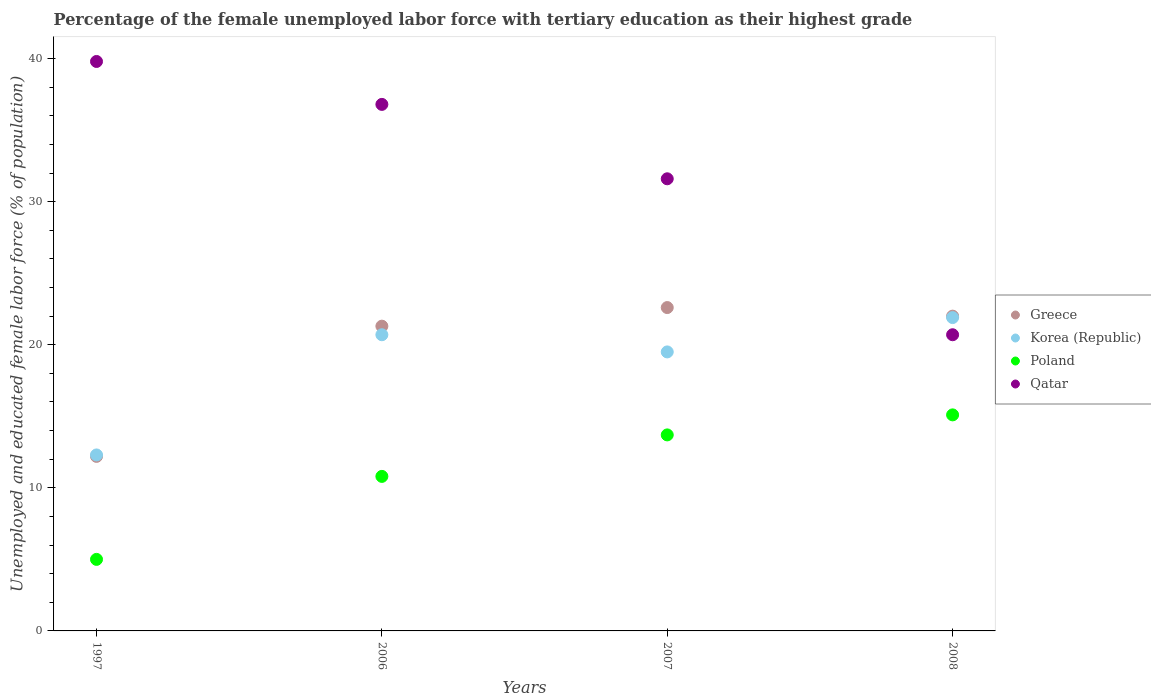Is the number of dotlines equal to the number of legend labels?
Offer a very short reply. Yes. Across all years, what is the maximum percentage of the unemployed female labor force with tertiary education in Qatar?
Provide a short and direct response. 39.8. Across all years, what is the minimum percentage of the unemployed female labor force with tertiary education in Qatar?
Give a very brief answer. 20.7. What is the total percentage of the unemployed female labor force with tertiary education in Korea (Republic) in the graph?
Keep it short and to the point. 74.4. What is the difference between the percentage of the unemployed female labor force with tertiary education in Qatar in 2007 and that in 2008?
Provide a short and direct response. 10.9. What is the difference between the percentage of the unemployed female labor force with tertiary education in Greece in 2007 and the percentage of the unemployed female labor force with tertiary education in Qatar in 2008?
Offer a very short reply. 1.9. What is the average percentage of the unemployed female labor force with tertiary education in Greece per year?
Make the answer very short. 19.52. In the year 2008, what is the difference between the percentage of the unemployed female labor force with tertiary education in Greece and percentage of the unemployed female labor force with tertiary education in Poland?
Your response must be concise. 6.9. In how many years, is the percentage of the unemployed female labor force with tertiary education in Korea (Republic) greater than 38 %?
Provide a short and direct response. 0. What is the ratio of the percentage of the unemployed female labor force with tertiary education in Korea (Republic) in 1997 to that in 2007?
Your response must be concise. 0.63. Is the difference between the percentage of the unemployed female labor force with tertiary education in Greece in 1997 and 2007 greater than the difference between the percentage of the unemployed female labor force with tertiary education in Poland in 1997 and 2007?
Give a very brief answer. No. What is the difference between the highest and the second highest percentage of the unemployed female labor force with tertiary education in Korea (Republic)?
Ensure brevity in your answer.  1.2. What is the difference between the highest and the lowest percentage of the unemployed female labor force with tertiary education in Korea (Republic)?
Offer a very short reply. 9.6. In how many years, is the percentage of the unemployed female labor force with tertiary education in Greece greater than the average percentage of the unemployed female labor force with tertiary education in Greece taken over all years?
Keep it short and to the point. 3. Is it the case that in every year, the sum of the percentage of the unemployed female labor force with tertiary education in Korea (Republic) and percentage of the unemployed female labor force with tertiary education in Qatar  is greater than the sum of percentage of the unemployed female labor force with tertiary education in Greece and percentage of the unemployed female labor force with tertiary education in Poland?
Provide a succinct answer. Yes. Is it the case that in every year, the sum of the percentage of the unemployed female labor force with tertiary education in Poland and percentage of the unemployed female labor force with tertiary education in Qatar  is greater than the percentage of the unemployed female labor force with tertiary education in Korea (Republic)?
Make the answer very short. Yes. Is the percentage of the unemployed female labor force with tertiary education in Qatar strictly greater than the percentage of the unemployed female labor force with tertiary education in Greece over the years?
Provide a short and direct response. No. How many dotlines are there?
Give a very brief answer. 4. Does the graph contain grids?
Offer a terse response. No. How many legend labels are there?
Your response must be concise. 4. How are the legend labels stacked?
Make the answer very short. Vertical. What is the title of the graph?
Your answer should be compact. Percentage of the female unemployed labor force with tertiary education as their highest grade. Does "Gabon" appear as one of the legend labels in the graph?
Keep it short and to the point. No. What is the label or title of the Y-axis?
Your answer should be very brief. Unemployed and educated female labor force (% of population). What is the Unemployed and educated female labor force (% of population) of Greece in 1997?
Offer a terse response. 12.2. What is the Unemployed and educated female labor force (% of population) in Korea (Republic) in 1997?
Keep it short and to the point. 12.3. What is the Unemployed and educated female labor force (% of population) of Poland in 1997?
Make the answer very short. 5. What is the Unemployed and educated female labor force (% of population) in Qatar in 1997?
Your response must be concise. 39.8. What is the Unemployed and educated female labor force (% of population) in Greece in 2006?
Keep it short and to the point. 21.3. What is the Unemployed and educated female labor force (% of population) of Korea (Republic) in 2006?
Your response must be concise. 20.7. What is the Unemployed and educated female labor force (% of population) in Poland in 2006?
Your response must be concise. 10.8. What is the Unemployed and educated female labor force (% of population) of Qatar in 2006?
Your answer should be compact. 36.8. What is the Unemployed and educated female labor force (% of population) in Greece in 2007?
Offer a terse response. 22.6. What is the Unemployed and educated female labor force (% of population) of Poland in 2007?
Your response must be concise. 13.7. What is the Unemployed and educated female labor force (% of population) of Qatar in 2007?
Your answer should be compact. 31.6. What is the Unemployed and educated female labor force (% of population) in Greece in 2008?
Make the answer very short. 22. What is the Unemployed and educated female labor force (% of population) of Korea (Republic) in 2008?
Give a very brief answer. 21.9. What is the Unemployed and educated female labor force (% of population) of Poland in 2008?
Give a very brief answer. 15.1. What is the Unemployed and educated female labor force (% of population) of Qatar in 2008?
Ensure brevity in your answer.  20.7. Across all years, what is the maximum Unemployed and educated female labor force (% of population) in Greece?
Keep it short and to the point. 22.6. Across all years, what is the maximum Unemployed and educated female labor force (% of population) in Korea (Republic)?
Keep it short and to the point. 21.9. Across all years, what is the maximum Unemployed and educated female labor force (% of population) in Poland?
Provide a short and direct response. 15.1. Across all years, what is the maximum Unemployed and educated female labor force (% of population) in Qatar?
Keep it short and to the point. 39.8. Across all years, what is the minimum Unemployed and educated female labor force (% of population) of Greece?
Ensure brevity in your answer.  12.2. Across all years, what is the minimum Unemployed and educated female labor force (% of population) of Korea (Republic)?
Make the answer very short. 12.3. Across all years, what is the minimum Unemployed and educated female labor force (% of population) in Qatar?
Give a very brief answer. 20.7. What is the total Unemployed and educated female labor force (% of population) in Greece in the graph?
Offer a terse response. 78.1. What is the total Unemployed and educated female labor force (% of population) of Korea (Republic) in the graph?
Give a very brief answer. 74.4. What is the total Unemployed and educated female labor force (% of population) in Poland in the graph?
Ensure brevity in your answer.  44.6. What is the total Unemployed and educated female labor force (% of population) in Qatar in the graph?
Your answer should be very brief. 128.9. What is the difference between the Unemployed and educated female labor force (% of population) of Greece in 1997 and that in 2006?
Make the answer very short. -9.1. What is the difference between the Unemployed and educated female labor force (% of population) of Korea (Republic) in 1997 and that in 2006?
Your response must be concise. -8.4. What is the difference between the Unemployed and educated female labor force (% of population) in Greece in 1997 and that in 2007?
Offer a terse response. -10.4. What is the difference between the Unemployed and educated female labor force (% of population) in Qatar in 1997 and that in 2007?
Ensure brevity in your answer.  8.2. What is the difference between the Unemployed and educated female labor force (% of population) of Greece in 1997 and that in 2008?
Your answer should be very brief. -9.8. What is the difference between the Unemployed and educated female labor force (% of population) in Korea (Republic) in 1997 and that in 2008?
Offer a terse response. -9.6. What is the difference between the Unemployed and educated female labor force (% of population) in Poland in 1997 and that in 2008?
Give a very brief answer. -10.1. What is the difference between the Unemployed and educated female labor force (% of population) of Qatar in 1997 and that in 2008?
Keep it short and to the point. 19.1. What is the difference between the Unemployed and educated female labor force (% of population) of Greece in 2006 and that in 2007?
Ensure brevity in your answer.  -1.3. What is the difference between the Unemployed and educated female labor force (% of population) of Korea (Republic) in 2006 and that in 2007?
Your answer should be compact. 1.2. What is the difference between the Unemployed and educated female labor force (% of population) in Poland in 2006 and that in 2007?
Offer a very short reply. -2.9. What is the difference between the Unemployed and educated female labor force (% of population) of Qatar in 2006 and that in 2007?
Your answer should be compact. 5.2. What is the difference between the Unemployed and educated female labor force (% of population) in Greece in 2006 and that in 2008?
Keep it short and to the point. -0.7. What is the difference between the Unemployed and educated female labor force (% of population) of Korea (Republic) in 2006 and that in 2008?
Your answer should be very brief. -1.2. What is the difference between the Unemployed and educated female labor force (% of population) of Poland in 2006 and that in 2008?
Your answer should be compact. -4.3. What is the difference between the Unemployed and educated female labor force (% of population) of Greece in 2007 and that in 2008?
Provide a succinct answer. 0.6. What is the difference between the Unemployed and educated female labor force (% of population) in Korea (Republic) in 2007 and that in 2008?
Your answer should be compact. -2.4. What is the difference between the Unemployed and educated female labor force (% of population) of Poland in 2007 and that in 2008?
Provide a short and direct response. -1.4. What is the difference between the Unemployed and educated female labor force (% of population) of Greece in 1997 and the Unemployed and educated female labor force (% of population) of Korea (Republic) in 2006?
Your response must be concise. -8.5. What is the difference between the Unemployed and educated female labor force (% of population) of Greece in 1997 and the Unemployed and educated female labor force (% of population) of Poland in 2006?
Keep it short and to the point. 1.4. What is the difference between the Unemployed and educated female labor force (% of population) in Greece in 1997 and the Unemployed and educated female labor force (% of population) in Qatar in 2006?
Your answer should be very brief. -24.6. What is the difference between the Unemployed and educated female labor force (% of population) in Korea (Republic) in 1997 and the Unemployed and educated female labor force (% of population) in Qatar in 2006?
Your answer should be very brief. -24.5. What is the difference between the Unemployed and educated female labor force (% of population) of Poland in 1997 and the Unemployed and educated female labor force (% of population) of Qatar in 2006?
Your answer should be compact. -31.8. What is the difference between the Unemployed and educated female labor force (% of population) of Greece in 1997 and the Unemployed and educated female labor force (% of population) of Qatar in 2007?
Your answer should be very brief. -19.4. What is the difference between the Unemployed and educated female labor force (% of population) of Korea (Republic) in 1997 and the Unemployed and educated female labor force (% of population) of Poland in 2007?
Make the answer very short. -1.4. What is the difference between the Unemployed and educated female labor force (% of population) in Korea (Republic) in 1997 and the Unemployed and educated female labor force (% of population) in Qatar in 2007?
Give a very brief answer. -19.3. What is the difference between the Unemployed and educated female labor force (% of population) of Poland in 1997 and the Unemployed and educated female labor force (% of population) of Qatar in 2007?
Offer a very short reply. -26.6. What is the difference between the Unemployed and educated female labor force (% of population) of Greece in 1997 and the Unemployed and educated female labor force (% of population) of Poland in 2008?
Your answer should be very brief. -2.9. What is the difference between the Unemployed and educated female labor force (% of population) of Greece in 1997 and the Unemployed and educated female labor force (% of population) of Qatar in 2008?
Your answer should be compact. -8.5. What is the difference between the Unemployed and educated female labor force (% of population) of Poland in 1997 and the Unemployed and educated female labor force (% of population) of Qatar in 2008?
Give a very brief answer. -15.7. What is the difference between the Unemployed and educated female labor force (% of population) in Greece in 2006 and the Unemployed and educated female labor force (% of population) in Poland in 2007?
Your response must be concise. 7.6. What is the difference between the Unemployed and educated female labor force (% of population) of Korea (Republic) in 2006 and the Unemployed and educated female labor force (% of population) of Poland in 2007?
Offer a very short reply. 7. What is the difference between the Unemployed and educated female labor force (% of population) in Korea (Republic) in 2006 and the Unemployed and educated female labor force (% of population) in Qatar in 2007?
Provide a succinct answer. -10.9. What is the difference between the Unemployed and educated female labor force (% of population) of Poland in 2006 and the Unemployed and educated female labor force (% of population) of Qatar in 2007?
Your answer should be compact. -20.8. What is the difference between the Unemployed and educated female labor force (% of population) in Greece in 2006 and the Unemployed and educated female labor force (% of population) in Qatar in 2008?
Offer a very short reply. 0.6. What is the difference between the Unemployed and educated female labor force (% of population) in Korea (Republic) in 2006 and the Unemployed and educated female labor force (% of population) in Qatar in 2008?
Your response must be concise. 0. What is the difference between the Unemployed and educated female labor force (% of population) of Greece in 2007 and the Unemployed and educated female labor force (% of population) of Poland in 2008?
Offer a terse response. 7.5. What is the average Unemployed and educated female labor force (% of population) in Greece per year?
Provide a short and direct response. 19.52. What is the average Unemployed and educated female labor force (% of population) in Korea (Republic) per year?
Offer a very short reply. 18.6. What is the average Unemployed and educated female labor force (% of population) of Poland per year?
Provide a short and direct response. 11.15. What is the average Unemployed and educated female labor force (% of population) of Qatar per year?
Provide a succinct answer. 32.23. In the year 1997, what is the difference between the Unemployed and educated female labor force (% of population) in Greece and Unemployed and educated female labor force (% of population) in Qatar?
Keep it short and to the point. -27.6. In the year 1997, what is the difference between the Unemployed and educated female labor force (% of population) in Korea (Republic) and Unemployed and educated female labor force (% of population) in Qatar?
Provide a short and direct response. -27.5. In the year 1997, what is the difference between the Unemployed and educated female labor force (% of population) of Poland and Unemployed and educated female labor force (% of population) of Qatar?
Provide a succinct answer. -34.8. In the year 2006, what is the difference between the Unemployed and educated female labor force (% of population) of Greece and Unemployed and educated female labor force (% of population) of Korea (Republic)?
Your answer should be very brief. 0.6. In the year 2006, what is the difference between the Unemployed and educated female labor force (% of population) in Greece and Unemployed and educated female labor force (% of population) in Poland?
Ensure brevity in your answer.  10.5. In the year 2006, what is the difference between the Unemployed and educated female labor force (% of population) of Greece and Unemployed and educated female labor force (% of population) of Qatar?
Offer a terse response. -15.5. In the year 2006, what is the difference between the Unemployed and educated female labor force (% of population) in Korea (Republic) and Unemployed and educated female labor force (% of population) in Qatar?
Give a very brief answer. -16.1. In the year 2006, what is the difference between the Unemployed and educated female labor force (% of population) of Poland and Unemployed and educated female labor force (% of population) of Qatar?
Give a very brief answer. -26. In the year 2007, what is the difference between the Unemployed and educated female labor force (% of population) in Greece and Unemployed and educated female labor force (% of population) in Korea (Republic)?
Provide a short and direct response. 3.1. In the year 2007, what is the difference between the Unemployed and educated female labor force (% of population) of Greece and Unemployed and educated female labor force (% of population) of Poland?
Offer a terse response. 8.9. In the year 2007, what is the difference between the Unemployed and educated female labor force (% of population) in Greece and Unemployed and educated female labor force (% of population) in Qatar?
Offer a very short reply. -9. In the year 2007, what is the difference between the Unemployed and educated female labor force (% of population) in Korea (Republic) and Unemployed and educated female labor force (% of population) in Qatar?
Your response must be concise. -12.1. In the year 2007, what is the difference between the Unemployed and educated female labor force (% of population) in Poland and Unemployed and educated female labor force (% of population) in Qatar?
Offer a terse response. -17.9. In the year 2008, what is the difference between the Unemployed and educated female labor force (% of population) of Greece and Unemployed and educated female labor force (% of population) of Qatar?
Make the answer very short. 1.3. In the year 2008, what is the difference between the Unemployed and educated female labor force (% of population) of Korea (Republic) and Unemployed and educated female labor force (% of population) of Poland?
Keep it short and to the point. 6.8. In the year 2008, what is the difference between the Unemployed and educated female labor force (% of population) of Korea (Republic) and Unemployed and educated female labor force (% of population) of Qatar?
Ensure brevity in your answer.  1.2. In the year 2008, what is the difference between the Unemployed and educated female labor force (% of population) in Poland and Unemployed and educated female labor force (% of population) in Qatar?
Provide a short and direct response. -5.6. What is the ratio of the Unemployed and educated female labor force (% of population) in Greece in 1997 to that in 2006?
Make the answer very short. 0.57. What is the ratio of the Unemployed and educated female labor force (% of population) of Korea (Republic) in 1997 to that in 2006?
Your answer should be very brief. 0.59. What is the ratio of the Unemployed and educated female labor force (% of population) of Poland in 1997 to that in 2006?
Offer a very short reply. 0.46. What is the ratio of the Unemployed and educated female labor force (% of population) of Qatar in 1997 to that in 2006?
Keep it short and to the point. 1.08. What is the ratio of the Unemployed and educated female labor force (% of population) in Greece in 1997 to that in 2007?
Offer a very short reply. 0.54. What is the ratio of the Unemployed and educated female labor force (% of population) of Korea (Republic) in 1997 to that in 2007?
Make the answer very short. 0.63. What is the ratio of the Unemployed and educated female labor force (% of population) in Poland in 1997 to that in 2007?
Your response must be concise. 0.36. What is the ratio of the Unemployed and educated female labor force (% of population) of Qatar in 1997 to that in 2007?
Your answer should be very brief. 1.26. What is the ratio of the Unemployed and educated female labor force (% of population) in Greece in 1997 to that in 2008?
Provide a succinct answer. 0.55. What is the ratio of the Unemployed and educated female labor force (% of population) of Korea (Republic) in 1997 to that in 2008?
Ensure brevity in your answer.  0.56. What is the ratio of the Unemployed and educated female labor force (% of population) in Poland in 1997 to that in 2008?
Ensure brevity in your answer.  0.33. What is the ratio of the Unemployed and educated female labor force (% of population) of Qatar in 1997 to that in 2008?
Provide a succinct answer. 1.92. What is the ratio of the Unemployed and educated female labor force (% of population) in Greece in 2006 to that in 2007?
Your answer should be very brief. 0.94. What is the ratio of the Unemployed and educated female labor force (% of population) in Korea (Republic) in 2006 to that in 2007?
Make the answer very short. 1.06. What is the ratio of the Unemployed and educated female labor force (% of population) in Poland in 2006 to that in 2007?
Provide a short and direct response. 0.79. What is the ratio of the Unemployed and educated female labor force (% of population) of Qatar in 2006 to that in 2007?
Offer a very short reply. 1.16. What is the ratio of the Unemployed and educated female labor force (% of population) of Greece in 2006 to that in 2008?
Keep it short and to the point. 0.97. What is the ratio of the Unemployed and educated female labor force (% of population) in Korea (Republic) in 2006 to that in 2008?
Provide a short and direct response. 0.95. What is the ratio of the Unemployed and educated female labor force (% of population) in Poland in 2006 to that in 2008?
Make the answer very short. 0.72. What is the ratio of the Unemployed and educated female labor force (% of population) of Qatar in 2006 to that in 2008?
Give a very brief answer. 1.78. What is the ratio of the Unemployed and educated female labor force (% of population) in Greece in 2007 to that in 2008?
Make the answer very short. 1.03. What is the ratio of the Unemployed and educated female labor force (% of population) of Korea (Republic) in 2007 to that in 2008?
Offer a very short reply. 0.89. What is the ratio of the Unemployed and educated female labor force (% of population) in Poland in 2007 to that in 2008?
Offer a very short reply. 0.91. What is the ratio of the Unemployed and educated female labor force (% of population) in Qatar in 2007 to that in 2008?
Offer a very short reply. 1.53. What is the difference between the highest and the second highest Unemployed and educated female labor force (% of population) in Korea (Republic)?
Make the answer very short. 1.2. 